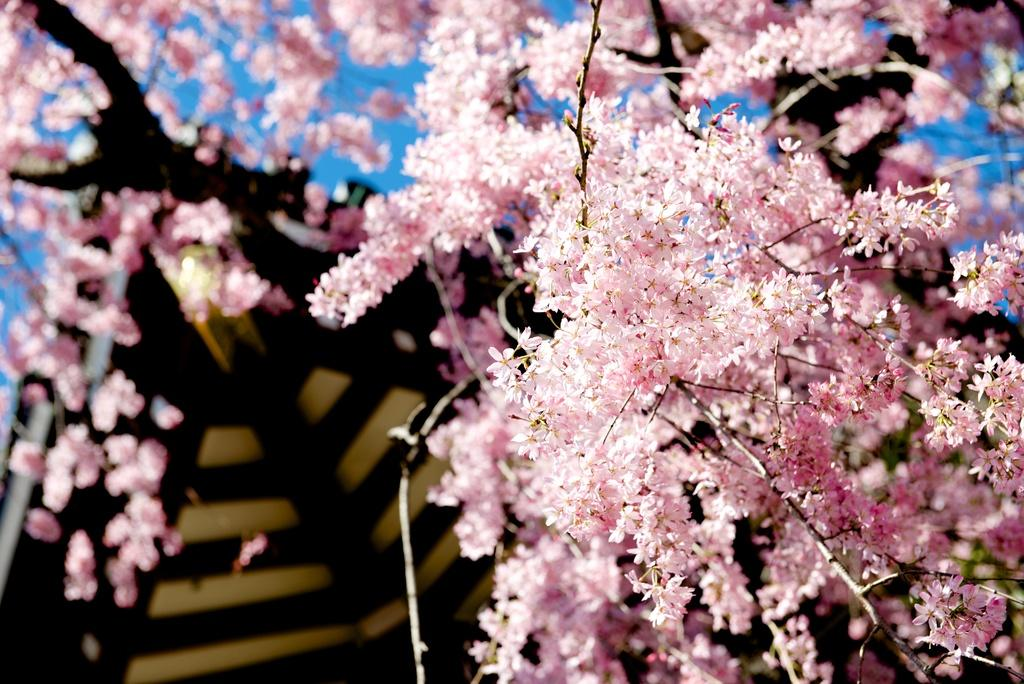What type of living organisms can be seen in the image? There are flowers in the image. What part of the natural environment is visible in the image? The sky is visible in the image. What type of bells can be heard ringing in the image? There are no bells present in the image, and therefore no sound can be heard. What type of light source is illuminating the flowers in the image? The facts provided do not mention any specific light source; it could be natural sunlight or artificial light. 